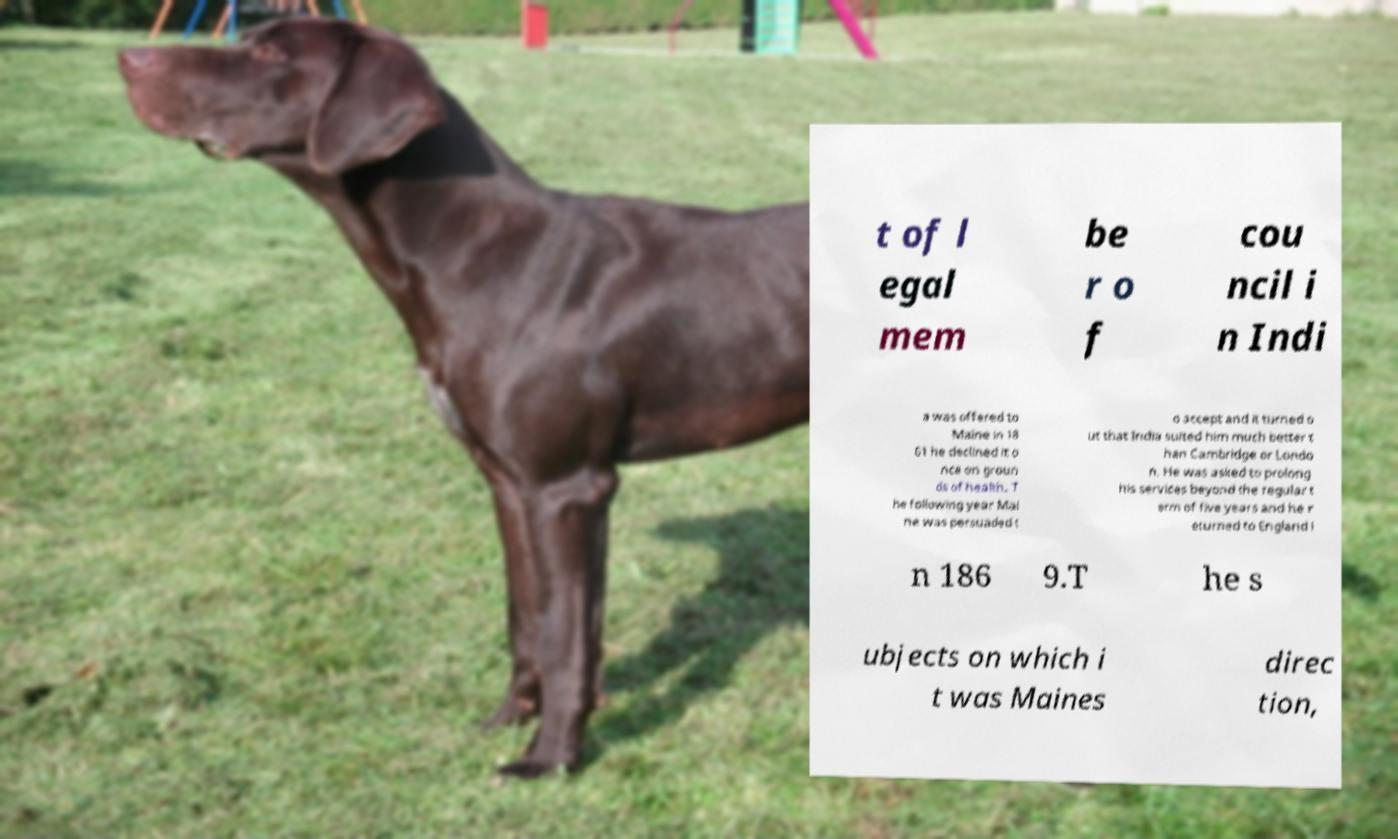Could you extract and type out the text from this image? t of l egal mem be r o f cou ncil i n Indi a was offered to Maine in 18 61 he declined it o nce on groun ds of health. T he following year Mai ne was persuaded t o accept and it turned o ut that India suited him much better t han Cambridge or Londo n. He was asked to prolong his services beyond the regular t erm of five years and he r eturned to England i n 186 9.T he s ubjects on which i t was Maines direc tion, 